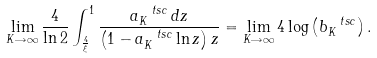<formula> <loc_0><loc_0><loc_500><loc_500>\lim _ { K \rightarrow \infty } \frac { 4 } { \ln 2 } \int _ { \frac { 4 } { \xi } } ^ { 1 } \frac { a ^ { \ t s c } _ { K } \, d z } { \left ( 1 - a ^ { \ t s c } _ { K } \ln z \right ) z } = \lim _ { K \rightarrow \infty } 4 \log \left ( b ^ { \ t s c } _ { K } \right ) .</formula> 